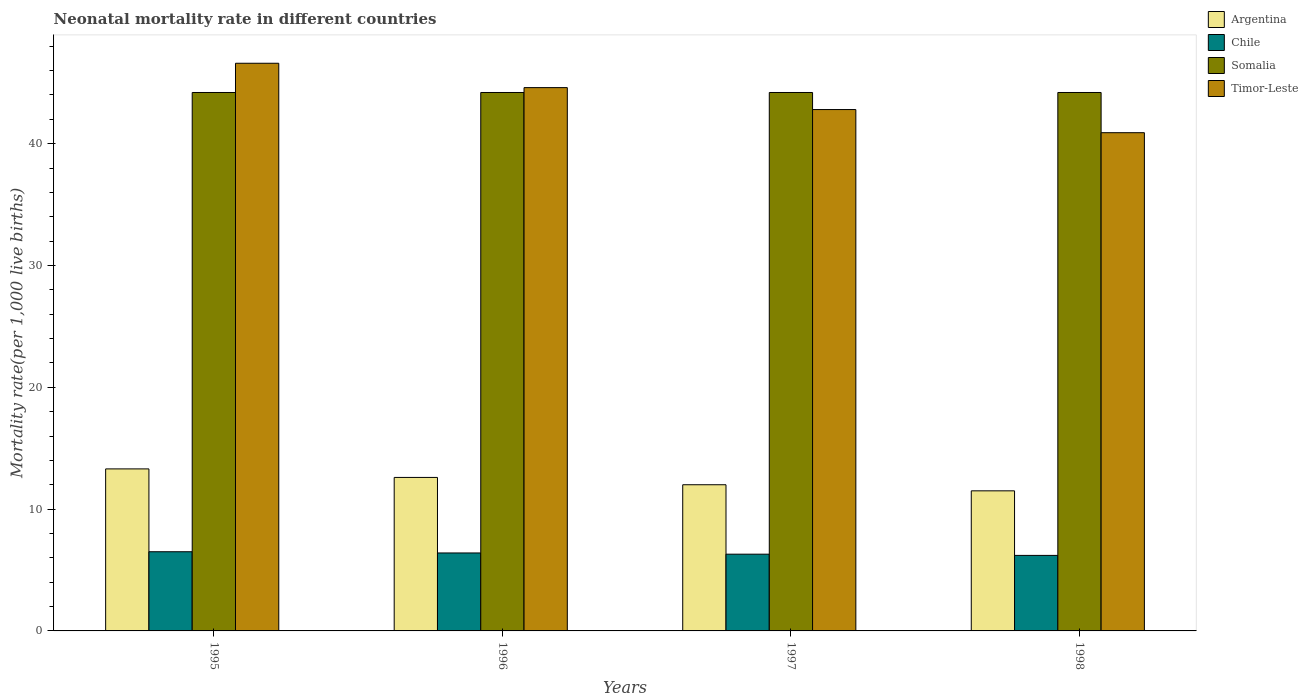How many groups of bars are there?
Keep it short and to the point. 4. Are the number of bars per tick equal to the number of legend labels?
Provide a succinct answer. Yes. How many bars are there on the 3rd tick from the left?
Offer a terse response. 4. How many bars are there on the 1st tick from the right?
Your answer should be compact. 4. In how many cases, is the number of bars for a given year not equal to the number of legend labels?
Provide a short and direct response. 0. What is the neonatal mortality rate in Somalia in 1995?
Make the answer very short. 44.2. Across all years, what is the maximum neonatal mortality rate in Argentina?
Ensure brevity in your answer.  13.3. Across all years, what is the minimum neonatal mortality rate in Timor-Leste?
Keep it short and to the point. 40.9. In which year was the neonatal mortality rate in Argentina minimum?
Provide a succinct answer. 1998. What is the total neonatal mortality rate in Somalia in the graph?
Give a very brief answer. 176.8. What is the difference between the neonatal mortality rate in Timor-Leste in 1995 and that in 1998?
Keep it short and to the point. 5.7. What is the difference between the neonatal mortality rate in Argentina in 1998 and the neonatal mortality rate in Somalia in 1997?
Keep it short and to the point. -32.7. What is the average neonatal mortality rate in Chile per year?
Provide a succinct answer. 6.35. What is the ratio of the neonatal mortality rate in Chile in 1997 to that in 1998?
Ensure brevity in your answer.  1.02. Is the difference between the neonatal mortality rate in Chile in 1997 and 1998 greater than the difference between the neonatal mortality rate in Argentina in 1997 and 1998?
Your response must be concise. No. What is the difference between the highest and the second highest neonatal mortality rate in Timor-Leste?
Offer a very short reply. 2. What is the difference between the highest and the lowest neonatal mortality rate in Somalia?
Offer a very short reply. 0. In how many years, is the neonatal mortality rate in Argentina greater than the average neonatal mortality rate in Argentina taken over all years?
Ensure brevity in your answer.  2. Is the sum of the neonatal mortality rate in Somalia in 1996 and 1997 greater than the maximum neonatal mortality rate in Timor-Leste across all years?
Provide a succinct answer. Yes. What does the 3rd bar from the left in 1996 represents?
Offer a terse response. Somalia. What does the 1st bar from the right in 1996 represents?
Give a very brief answer. Timor-Leste. Is it the case that in every year, the sum of the neonatal mortality rate in Argentina and neonatal mortality rate in Chile is greater than the neonatal mortality rate in Timor-Leste?
Give a very brief answer. No. Are all the bars in the graph horizontal?
Offer a terse response. No. What is the difference between two consecutive major ticks on the Y-axis?
Your answer should be very brief. 10. Does the graph contain any zero values?
Offer a terse response. No. Does the graph contain grids?
Your answer should be very brief. No. Where does the legend appear in the graph?
Your answer should be compact. Top right. What is the title of the graph?
Your response must be concise. Neonatal mortality rate in different countries. What is the label or title of the Y-axis?
Provide a short and direct response. Mortality rate(per 1,0 live births). What is the Mortality rate(per 1,000 live births) of Argentina in 1995?
Your response must be concise. 13.3. What is the Mortality rate(per 1,000 live births) in Chile in 1995?
Give a very brief answer. 6.5. What is the Mortality rate(per 1,000 live births) in Somalia in 1995?
Provide a short and direct response. 44.2. What is the Mortality rate(per 1,000 live births) in Timor-Leste in 1995?
Your response must be concise. 46.6. What is the Mortality rate(per 1,000 live births) in Argentina in 1996?
Ensure brevity in your answer.  12.6. What is the Mortality rate(per 1,000 live births) in Chile in 1996?
Your answer should be compact. 6.4. What is the Mortality rate(per 1,000 live births) in Somalia in 1996?
Your answer should be very brief. 44.2. What is the Mortality rate(per 1,000 live births) in Timor-Leste in 1996?
Your answer should be very brief. 44.6. What is the Mortality rate(per 1,000 live births) in Argentina in 1997?
Your answer should be compact. 12. What is the Mortality rate(per 1,000 live births) of Chile in 1997?
Your answer should be compact. 6.3. What is the Mortality rate(per 1,000 live births) of Somalia in 1997?
Your response must be concise. 44.2. What is the Mortality rate(per 1,000 live births) in Timor-Leste in 1997?
Offer a very short reply. 42.8. What is the Mortality rate(per 1,000 live births) of Chile in 1998?
Ensure brevity in your answer.  6.2. What is the Mortality rate(per 1,000 live births) of Somalia in 1998?
Keep it short and to the point. 44.2. What is the Mortality rate(per 1,000 live births) of Timor-Leste in 1998?
Your answer should be compact. 40.9. Across all years, what is the maximum Mortality rate(per 1,000 live births) in Argentina?
Provide a succinct answer. 13.3. Across all years, what is the maximum Mortality rate(per 1,000 live births) of Somalia?
Keep it short and to the point. 44.2. Across all years, what is the maximum Mortality rate(per 1,000 live births) in Timor-Leste?
Keep it short and to the point. 46.6. Across all years, what is the minimum Mortality rate(per 1,000 live births) of Somalia?
Offer a terse response. 44.2. Across all years, what is the minimum Mortality rate(per 1,000 live births) in Timor-Leste?
Ensure brevity in your answer.  40.9. What is the total Mortality rate(per 1,000 live births) of Argentina in the graph?
Your response must be concise. 49.4. What is the total Mortality rate(per 1,000 live births) of Chile in the graph?
Make the answer very short. 25.4. What is the total Mortality rate(per 1,000 live births) of Somalia in the graph?
Provide a short and direct response. 176.8. What is the total Mortality rate(per 1,000 live births) of Timor-Leste in the graph?
Give a very brief answer. 174.9. What is the difference between the Mortality rate(per 1,000 live births) in Chile in 1995 and that in 1996?
Give a very brief answer. 0.1. What is the difference between the Mortality rate(per 1,000 live births) of Argentina in 1995 and that in 1997?
Make the answer very short. 1.3. What is the difference between the Mortality rate(per 1,000 live births) of Chile in 1995 and that in 1998?
Give a very brief answer. 0.3. What is the difference between the Mortality rate(per 1,000 live births) in Timor-Leste in 1995 and that in 1998?
Your answer should be compact. 5.7. What is the difference between the Mortality rate(per 1,000 live births) of Chile in 1996 and that in 1997?
Your answer should be very brief. 0.1. What is the difference between the Mortality rate(per 1,000 live births) of Somalia in 1996 and that in 1997?
Give a very brief answer. 0. What is the difference between the Mortality rate(per 1,000 live births) in Argentina in 1996 and that in 1998?
Your answer should be very brief. 1.1. What is the difference between the Mortality rate(per 1,000 live births) of Chile in 1996 and that in 1998?
Offer a terse response. 0.2. What is the difference between the Mortality rate(per 1,000 live births) of Somalia in 1996 and that in 1998?
Make the answer very short. 0. What is the difference between the Mortality rate(per 1,000 live births) in Timor-Leste in 1996 and that in 1998?
Make the answer very short. 3.7. What is the difference between the Mortality rate(per 1,000 live births) of Somalia in 1997 and that in 1998?
Offer a very short reply. 0. What is the difference between the Mortality rate(per 1,000 live births) in Timor-Leste in 1997 and that in 1998?
Offer a terse response. 1.9. What is the difference between the Mortality rate(per 1,000 live births) of Argentina in 1995 and the Mortality rate(per 1,000 live births) of Somalia in 1996?
Your response must be concise. -30.9. What is the difference between the Mortality rate(per 1,000 live births) in Argentina in 1995 and the Mortality rate(per 1,000 live births) in Timor-Leste in 1996?
Offer a very short reply. -31.3. What is the difference between the Mortality rate(per 1,000 live births) in Chile in 1995 and the Mortality rate(per 1,000 live births) in Somalia in 1996?
Your response must be concise. -37.7. What is the difference between the Mortality rate(per 1,000 live births) of Chile in 1995 and the Mortality rate(per 1,000 live births) of Timor-Leste in 1996?
Make the answer very short. -38.1. What is the difference between the Mortality rate(per 1,000 live births) of Somalia in 1995 and the Mortality rate(per 1,000 live births) of Timor-Leste in 1996?
Provide a short and direct response. -0.4. What is the difference between the Mortality rate(per 1,000 live births) of Argentina in 1995 and the Mortality rate(per 1,000 live births) of Chile in 1997?
Offer a terse response. 7. What is the difference between the Mortality rate(per 1,000 live births) of Argentina in 1995 and the Mortality rate(per 1,000 live births) of Somalia in 1997?
Keep it short and to the point. -30.9. What is the difference between the Mortality rate(per 1,000 live births) in Argentina in 1995 and the Mortality rate(per 1,000 live births) in Timor-Leste in 1997?
Your answer should be very brief. -29.5. What is the difference between the Mortality rate(per 1,000 live births) in Chile in 1995 and the Mortality rate(per 1,000 live births) in Somalia in 1997?
Offer a terse response. -37.7. What is the difference between the Mortality rate(per 1,000 live births) of Chile in 1995 and the Mortality rate(per 1,000 live births) of Timor-Leste in 1997?
Provide a succinct answer. -36.3. What is the difference between the Mortality rate(per 1,000 live births) of Argentina in 1995 and the Mortality rate(per 1,000 live births) of Somalia in 1998?
Your response must be concise. -30.9. What is the difference between the Mortality rate(per 1,000 live births) in Argentina in 1995 and the Mortality rate(per 1,000 live births) in Timor-Leste in 1998?
Your answer should be compact. -27.6. What is the difference between the Mortality rate(per 1,000 live births) in Chile in 1995 and the Mortality rate(per 1,000 live births) in Somalia in 1998?
Your answer should be very brief. -37.7. What is the difference between the Mortality rate(per 1,000 live births) of Chile in 1995 and the Mortality rate(per 1,000 live births) of Timor-Leste in 1998?
Make the answer very short. -34.4. What is the difference between the Mortality rate(per 1,000 live births) of Argentina in 1996 and the Mortality rate(per 1,000 live births) of Chile in 1997?
Make the answer very short. 6.3. What is the difference between the Mortality rate(per 1,000 live births) of Argentina in 1996 and the Mortality rate(per 1,000 live births) of Somalia in 1997?
Provide a short and direct response. -31.6. What is the difference between the Mortality rate(per 1,000 live births) of Argentina in 1996 and the Mortality rate(per 1,000 live births) of Timor-Leste in 1997?
Your answer should be very brief. -30.2. What is the difference between the Mortality rate(per 1,000 live births) of Chile in 1996 and the Mortality rate(per 1,000 live births) of Somalia in 1997?
Offer a very short reply. -37.8. What is the difference between the Mortality rate(per 1,000 live births) in Chile in 1996 and the Mortality rate(per 1,000 live births) in Timor-Leste in 1997?
Your response must be concise. -36.4. What is the difference between the Mortality rate(per 1,000 live births) in Argentina in 1996 and the Mortality rate(per 1,000 live births) in Chile in 1998?
Your answer should be very brief. 6.4. What is the difference between the Mortality rate(per 1,000 live births) in Argentina in 1996 and the Mortality rate(per 1,000 live births) in Somalia in 1998?
Keep it short and to the point. -31.6. What is the difference between the Mortality rate(per 1,000 live births) of Argentina in 1996 and the Mortality rate(per 1,000 live births) of Timor-Leste in 1998?
Keep it short and to the point. -28.3. What is the difference between the Mortality rate(per 1,000 live births) in Chile in 1996 and the Mortality rate(per 1,000 live births) in Somalia in 1998?
Offer a very short reply. -37.8. What is the difference between the Mortality rate(per 1,000 live births) of Chile in 1996 and the Mortality rate(per 1,000 live births) of Timor-Leste in 1998?
Your answer should be compact. -34.5. What is the difference between the Mortality rate(per 1,000 live births) in Argentina in 1997 and the Mortality rate(per 1,000 live births) in Somalia in 1998?
Your response must be concise. -32.2. What is the difference between the Mortality rate(per 1,000 live births) of Argentina in 1997 and the Mortality rate(per 1,000 live births) of Timor-Leste in 1998?
Offer a terse response. -28.9. What is the difference between the Mortality rate(per 1,000 live births) in Chile in 1997 and the Mortality rate(per 1,000 live births) in Somalia in 1998?
Provide a succinct answer. -37.9. What is the difference between the Mortality rate(per 1,000 live births) of Chile in 1997 and the Mortality rate(per 1,000 live births) of Timor-Leste in 1998?
Provide a succinct answer. -34.6. What is the difference between the Mortality rate(per 1,000 live births) in Somalia in 1997 and the Mortality rate(per 1,000 live births) in Timor-Leste in 1998?
Your response must be concise. 3.3. What is the average Mortality rate(per 1,000 live births) of Argentina per year?
Make the answer very short. 12.35. What is the average Mortality rate(per 1,000 live births) of Chile per year?
Your answer should be compact. 6.35. What is the average Mortality rate(per 1,000 live births) of Somalia per year?
Provide a succinct answer. 44.2. What is the average Mortality rate(per 1,000 live births) of Timor-Leste per year?
Give a very brief answer. 43.73. In the year 1995, what is the difference between the Mortality rate(per 1,000 live births) in Argentina and Mortality rate(per 1,000 live births) in Chile?
Your response must be concise. 6.8. In the year 1995, what is the difference between the Mortality rate(per 1,000 live births) in Argentina and Mortality rate(per 1,000 live births) in Somalia?
Give a very brief answer. -30.9. In the year 1995, what is the difference between the Mortality rate(per 1,000 live births) of Argentina and Mortality rate(per 1,000 live births) of Timor-Leste?
Ensure brevity in your answer.  -33.3. In the year 1995, what is the difference between the Mortality rate(per 1,000 live births) in Chile and Mortality rate(per 1,000 live births) in Somalia?
Give a very brief answer. -37.7. In the year 1995, what is the difference between the Mortality rate(per 1,000 live births) in Chile and Mortality rate(per 1,000 live births) in Timor-Leste?
Provide a short and direct response. -40.1. In the year 1996, what is the difference between the Mortality rate(per 1,000 live births) in Argentina and Mortality rate(per 1,000 live births) in Somalia?
Ensure brevity in your answer.  -31.6. In the year 1996, what is the difference between the Mortality rate(per 1,000 live births) of Argentina and Mortality rate(per 1,000 live births) of Timor-Leste?
Provide a succinct answer. -32. In the year 1996, what is the difference between the Mortality rate(per 1,000 live births) in Chile and Mortality rate(per 1,000 live births) in Somalia?
Ensure brevity in your answer.  -37.8. In the year 1996, what is the difference between the Mortality rate(per 1,000 live births) of Chile and Mortality rate(per 1,000 live births) of Timor-Leste?
Offer a very short reply. -38.2. In the year 1997, what is the difference between the Mortality rate(per 1,000 live births) in Argentina and Mortality rate(per 1,000 live births) in Chile?
Keep it short and to the point. 5.7. In the year 1997, what is the difference between the Mortality rate(per 1,000 live births) of Argentina and Mortality rate(per 1,000 live births) of Somalia?
Provide a short and direct response. -32.2. In the year 1997, what is the difference between the Mortality rate(per 1,000 live births) of Argentina and Mortality rate(per 1,000 live births) of Timor-Leste?
Keep it short and to the point. -30.8. In the year 1997, what is the difference between the Mortality rate(per 1,000 live births) of Chile and Mortality rate(per 1,000 live births) of Somalia?
Give a very brief answer. -37.9. In the year 1997, what is the difference between the Mortality rate(per 1,000 live births) of Chile and Mortality rate(per 1,000 live births) of Timor-Leste?
Give a very brief answer. -36.5. In the year 1997, what is the difference between the Mortality rate(per 1,000 live births) of Somalia and Mortality rate(per 1,000 live births) of Timor-Leste?
Offer a terse response. 1.4. In the year 1998, what is the difference between the Mortality rate(per 1,000 live births) in Argentina and Mortality rate(per 1,000 live births) in Somalia?
Provide a succinct answer. -32.7. In the year 1998, what is the difference between the Mortality rate(per 1,000 live births) of Argentina and Mortality rate(per 1,000 live births) of Timor-Leste?
Your response must be concise. -29.4. In the year 1998, what is the difference between the Mortality rate(per 1,000 live births) in Chile and Mortality rate(per 1,000 live births) in Somalia?
Provide a short and direct response. -38. In the year 1998, what is the difference between the Mortality rate(per 1,000 live births) in Chile and Mortality rate(per 1,000 live births) in Timor-Leste?
Your answer should be compact. -34.7. In the year 1998, what is the difference between the Mortality rate(per 1,000 live births) in Somalia and Mortality rate(per 1,000 live births) in Timor-Leste?
Provide a short and direct response. 3.3. What is the ratio of the Mortality rate(per 1,000 live births) in Argentina in 1995 to that in 1996?
Your answer should be compact. 1.06. What is the ratio of the Mortality rate(per 1,000 live births) of Chile in 1995 to that in 1996?
Provide a short and direct response. 1.02. What is the ratio of the Mortality rate(per 1,000 live births) in Timor-Leste in 1995 to that in 1996?
Provide a succinct answer. 1.04. What is the ratio of the Mortality rate(per 1,000 live births) in Argentina in 1995 to that in 1997?
Provide a succinct answer. 1.11. What is the ratio of the Mortality rate(per 1,000 live births) of Chile in 1995 to that in 1997?
Your answer should be compact. 1.03. What is the ratio of the Mortality rate(per 1,000 live births) of Timor-Leste in 1995 to that in 1997?
Your response must be concise. 1.09. What is the ratio of the Mortality rate(per 1,000 live births) in Argentina in 1995 to that in 1998?
Offer a very short reply. 1.16. What is the ratio of the Mortality rate(per 1,000 live births) of Chile in 1995 to that in 1998?
Your answer should be very brief. 1.05. What is the ratio of the Mortality rate(per 1,000 live births) of Timor-Leste in 1995 to that in 1998?
Provide a succinct answer. 1.14. What is the ratio of the Mortality rate(per 1,000 live births) of Chile in 1996 to that in 1997?
Provide a succinct answer. 1.02. What is the ratio of the Mortality rate(per 1,000 live births) in Timor-Leste in 1996 to that in 1997?
Offer a very short reply. 1.04. What is the ratio of the Mortality rate(per 1,000 live births) of Argentina in 1996 to that in 1998?
Offer a very short reply. 1.1. What is the ratio of the Mortality rate(per 1,000 live births) in Chile in 1996 to that in 1998?
Your answer should be compact. 1.03. What is the ratio of the Mortality rate(per 1,000 live births) in Timor-Leste in 1996 to that in 1998?
Your answer should be very brief. 1.09. What is the ratio of the Mortality rate(per 1,000 live births) of Argentina in 1997 to that in 1998?
Provide a succinct answer. 1.04. What is the ratio of the Mortality rate(per 1,000 live births) in Chile in 1997 to that in 1998?
Ensure brevity in your answer.  1.02. What is the ratio of the Mortality rate(per 1,000 live births) in Timor-Leste in 1997 to that in 1998?
Offer a terse response. 1.05. What is the difference between the highest and the second highest Mortality rate(per 1,000 live births) of Argentina?
Offer a terse response. 0.7. What is the difference between the highest and the second highest Mortality rate(per 1,000 live births) in Chile?
Offer a very short reply. 0.1. What is the difference between the highest and the lowest Mortality rate(per 1,000 live births) in Argentina?
Give a very brief answer. 1.8. What is the difference between the highest and the lowest Mortality rate(per 1,000 live births) of Chile?
Offer a terse response. 0.3. What is the difference between the highest and the lowest Mortality rate(per 1,000 live births) of Somalia?
Provide a short and direct response. 0. 